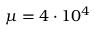Convert formula to latex. <formula><loc_0><loc_0><loc_500><loc_500>\mu = 4 \cdot 1 0 ^ { 4 }</formula> 